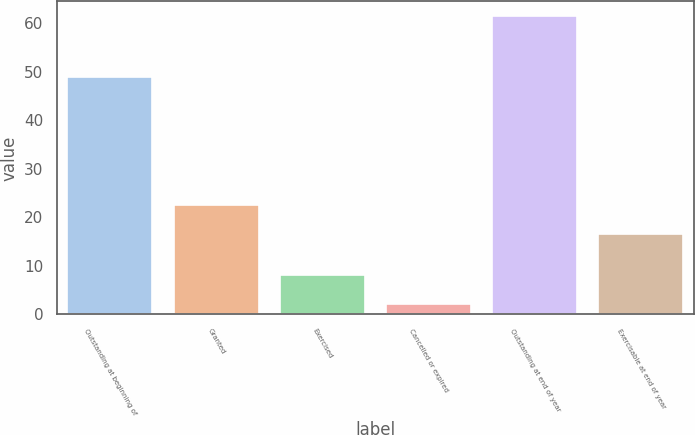Convert chart to OTSL. <chart><loc_0><loc_0><loc_500><loc_500><bar_chart><fcel>Outstanding at beginning of<fcel>Granted<fcel>Exercised<fcel>Cancelled or expired<fcel>Outstanding at end of year<fcel>Exercisable at end of year<nl><fcel>48.9<fcel>22.53<fcel>8.03<fcel>2.1<fcel>61.4<fcel>16.6<nl></chart> 